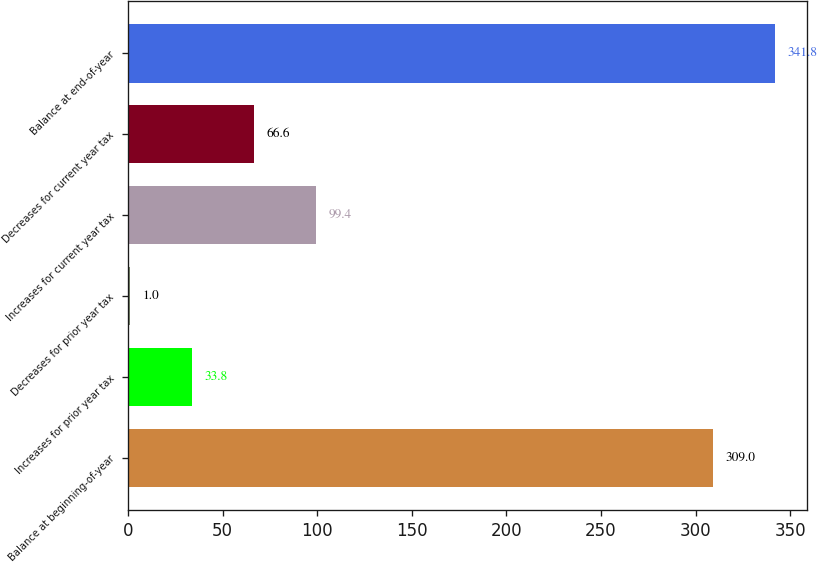Convert chart. <chart><loc_0><loc_0><loc_500><loc_500><bar_chart><fcel>Balance at beginning-of-year<fcel>Increases for prior year tax<fcel>Decreases for prior year tax<fcel>Increases for current year tax<fcel>Decreases for current year tax<fcel>Balance at end-of-year<nl><fcel>309<fcel>33.8<fcel>1<fcel>99.4<fcel>66.6<fcel>341.8<nl></chart> 